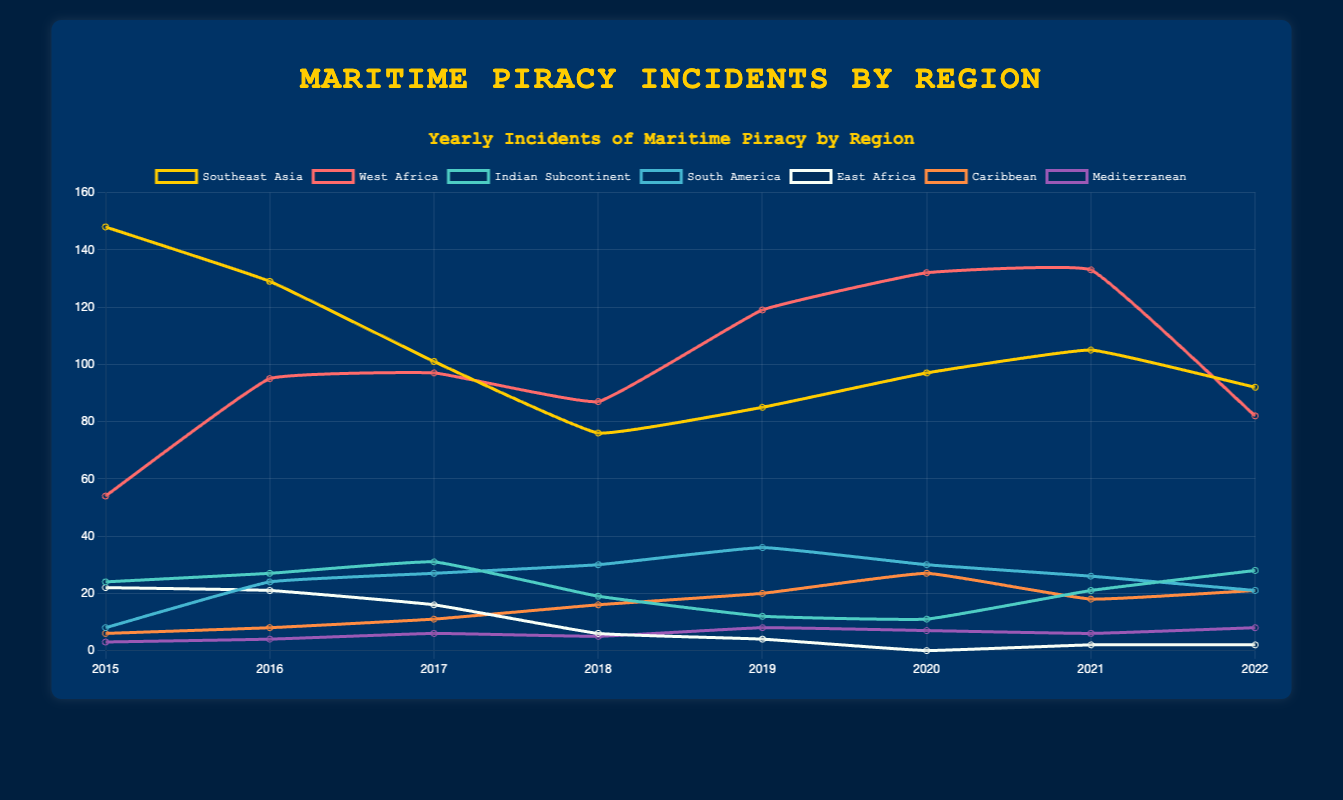Which region had the highest number of maritime piracy incidents in 2020? Look at the data label for the peak value in the year 2020. West Africa has the highest number of incidents with 132 for this year.
Answer: West Africa How did the number of incidents in Southeast Asia change from 2015 to 2022? Examine the trend line for Southeast Asia from 2015 to 2022. The data points show a decrease from 148 incidents in 2015 to 92 in 2022.
Answer: Decreased What is the average number of incidents in the Caribbean for the years provided? Add up the number of incidents for each year in the Caribbean (6 + 8 + 11 + 16 + 20 + 27 + 18 + 21) and divide by the number of years (8). The average is (127) / 8 = 15.875.
Answer: 15.875 Which region shows the most significant decline in incidents from 2015 to 2022? Compare the beginning and ending data points for each region. East Africa declines from 22 incidents in 2015 to 2 incidents in 2022.
Answer: East Africa Between 2015 and 2022, which region had the most consistent number of incidents with the least fluctuation? Observe the trend lines for each region. The Mediterranean shows the least fluctuation with incidents ranging from 3 to 8 annually.
Answer: Mediterranean How many total incidents were recorded in South America over the years depicted? Add the number of incidents for each year in South America (8 + 24 + 27 + 30 + 36 + 30 + 26 + 21). The total is 202.
Answer: 202 Which two years saw an increase in piracy incidents in Southeast Asia? Examine the trend line for Southeast Asia. There are increases from 2018 to 2019 (76 to 85) and 2019 to 2020 (85 to 97).
Answer: 2019 and 2020 Which year had the lowest number of total incidents in East Africa? Identify the data points for East Africa and find the minimum value. The year 2020 has the lowest total with 0 incidents.
Answer: 2020 What’s the difference in the number of incidents between the Caribbean and the Indian Subcontinent in 2022? Subtract the incidents in the Indian Subcontinent from those in the Caribbean for 2022. The difference is 21 - 28 = -7.
Answer: -7 Which year had the highest total number of incidents across all regions? Sum the incidents across all regions for each year and compare. The year 2015 has the highest total with 148 (Southeast Asia) + 54 (West Africa) + 24 (Indian Subcontinent) + 8 (South America) + 22 (East Africa) + 6 (Caribbean) + 3 (Mediterranean) = 265.
Answer: 2015 